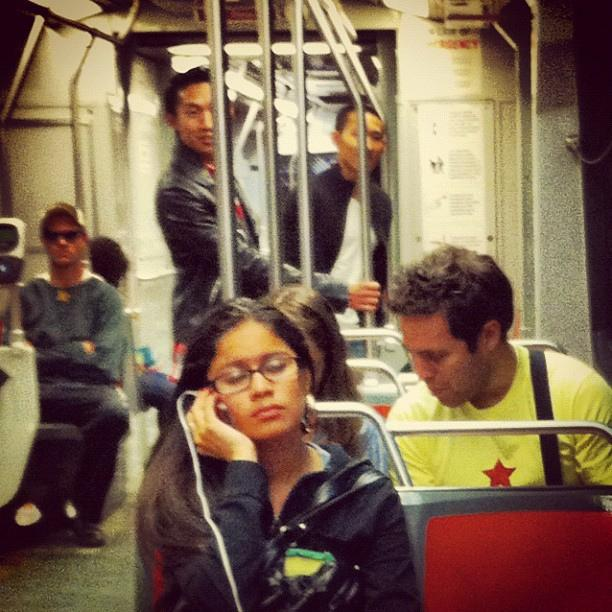The shape the man has on his yellow shirt is found on what flag? usa 